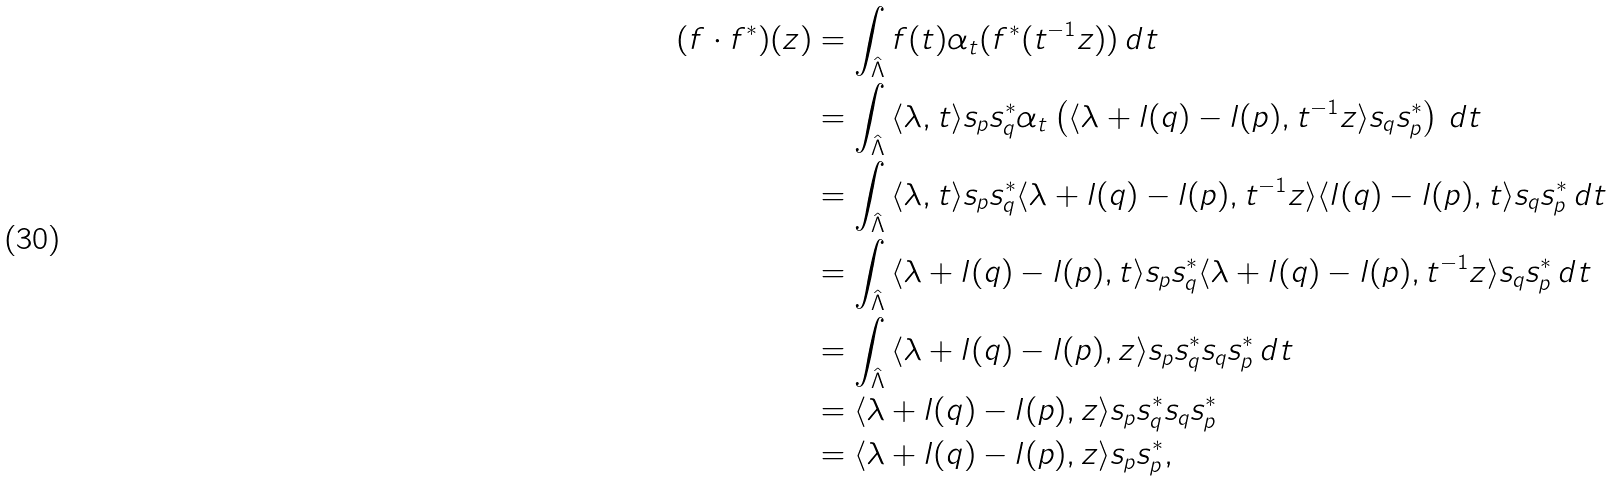<formula> <loc_0><loc_0><loc_500><loc_500>( f \cdot f ^ { * } ) ( z ) & = \int _ { \hat { \Lambda } } { f ( t ) \alpha _ { t } ( f ^ { * } ( t ^ { - 1 } z ) ) \, d t } \\ & = \int _ { \hat { \Lambda } } { \langle \lambda , t \rangle s _ { p } s _ { q } ^ { * } \alpha _ { t } \left ( \langle \lambda + l ( q ) - l ( p ) , t ^ { - 1 } z \rangle s _ { q } s _ { p } ^ { * } \right ) \, d t } \\ & = \int _ { \hat { \Lambda } } { \langle \lambda , t \rangle s _ { p } s _ { q } ^ { * } \langle \lambda + l ( q ) - l ( p ) , t ^ { - 1 } z \rangle \langle l ( q ) - l ( p ) , t \rangle s _ { q } s _ { p } ^ { * } \, d t } \\ & = \int _ { \hat { \Lambda } } { \langle \lambda + l ( q ) - l ( p ) , t \rangle s _ { p } s _ { q } ^ { * } \langle \lambda + l ( q ) - l ( p ) , t ^ { - 1 } z \rangle s _ { q } s _ { p } ^ { * } \, d t } \\ & = \int _ { \hat { \Lambda } } { \langle \lambda + l ( q ) - l ( p ) , z \rangle s _ { p } s _ { q } ^ { * } s _ { q } s _ { p } ^ { * } \, d t } \\ & = \langle \lambda + l ( q ) - l ( p ) , z \rangle s _ { p } s _ { q } ^ { * } s _ { q } s _ { p } ^ { * } \\ & = \langle \lambda + l ( q ) - l ( p ) , z \rangle s _ { p } s _ { p } ^ { * } , \\</formula> 